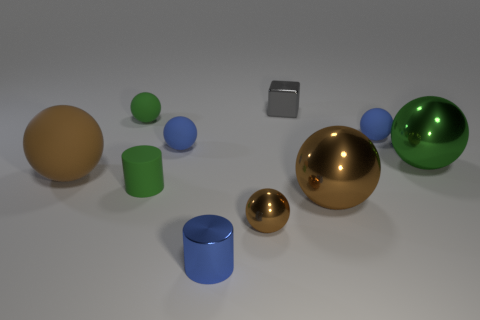Subtract all blue rubber balls. How many balls are left? 5 Subtract all blue cylinders. How many green spheres are left? 2 Subtract 1 cubes. How many cubes are left? 0 Subtract all green spheres. How many spheres are left? 5 Add 5 big brown objects. How many big brown objects are left? 7 Add 7 blue cylinders. How many blue cylinders exist? 8 Subtract 1 green balls. How many objects are left? 9 Subtract all cylinders. How many objects are left? 8 Subtract all blue cylinders. Subtract all gray spheres. How many cylinders are left? 1 Subtract all green spheres. Subtract all brown metallic objects. How many objects are left? 6 